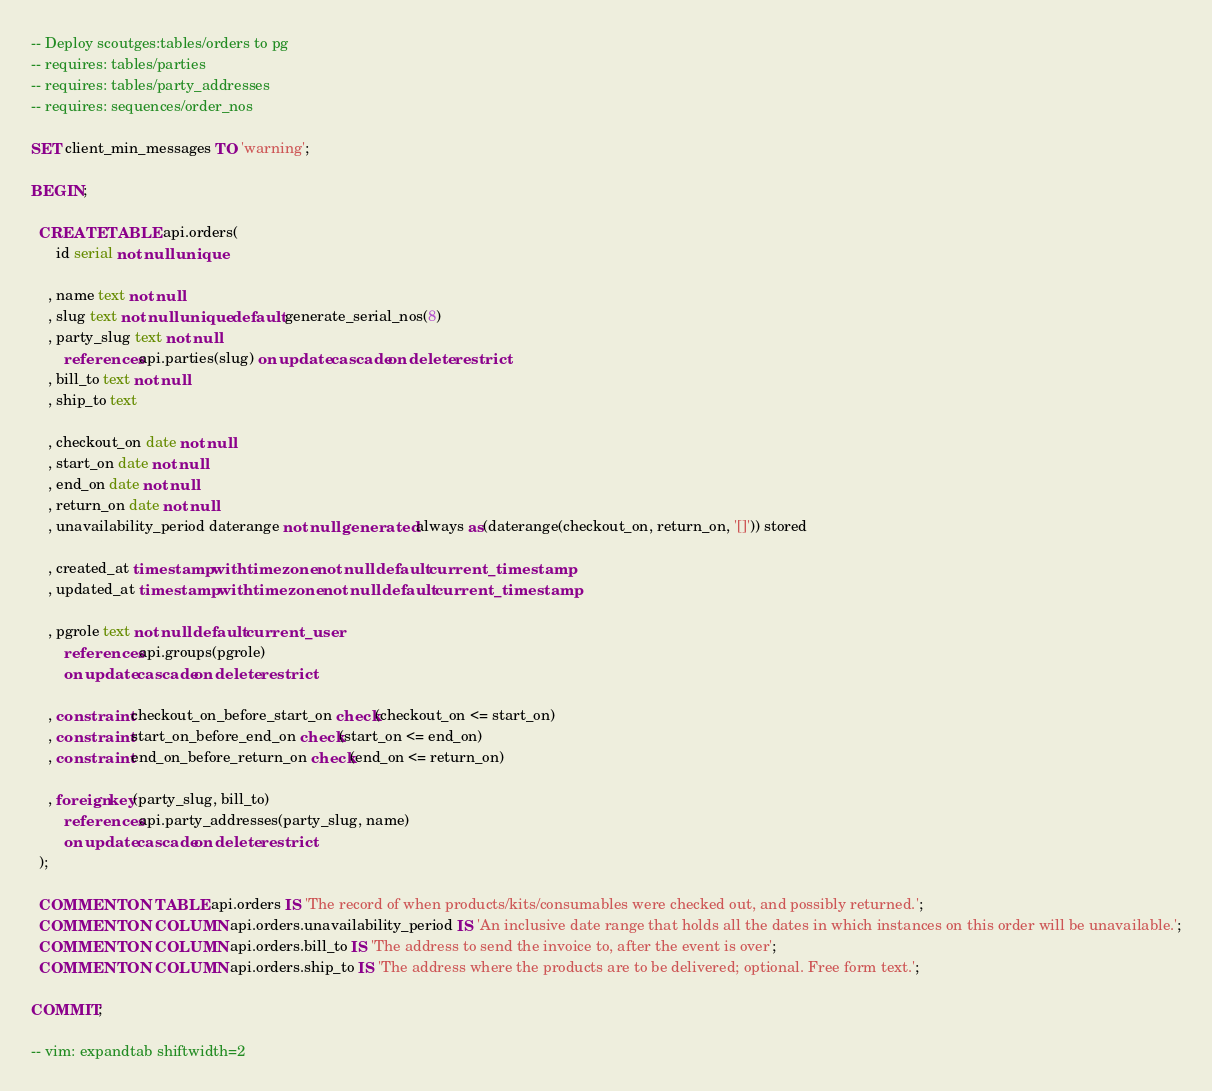<code> <loc_0><loc_0><loc_500><loc_500><_SQL_>-- Deploy scoutges:tables/orders to pg
-- requires: tables/parties
-- requires: tables/party_addresses
-- requires: sequences/order_nos

SET client_min_messages TO 'warning';

BEGIN;

  CREATE TABLE api.orders(
      id serial not null unique

    , name text not null
    , slug text not null unique default generate_serial_nos(8)
    , party_slug text not null
        references api.parties(slug) on update cascade on delete restrict
    , bill_to text not null
    , ship_to text

    , checkout_on date not null
    , start_on date not null
    , end_on date not null
    , return_on date not null
    , unavailability_period daterange not null generated always as(daterange(checkout_on, return_on, '[]')) stored

    , created_at timestamp with time zone not null default current_timestamp
    , updated_at timestamp with time zone not null default current_timestamp

    , pgrole text not null default current_user
        references api.groups(pgrole)
        on update cascade on delete restrict

    , constraint checkout_on_before_start_on check(checkout_on <= start_on)
    , constraint start_on_before_end_on check(start_on <= end_on)
    , constraint end_on_before_return_on check(end_on <= return_on)

    , foreign key(party_slug, bill_to)
        references api.party_addresses(party_slug, name)
        on update cascade on delete restrict
  );

  COMMENT ON TABLE api.orders IS 'The record of when products/kits/consumables were checked out, and possibly returned.';
  COMMENT ON COLUMN api.orders.unavailability_period IS 'An inclusive date range that holds all the dates in which instances on this order will be unavailable.';
  COMMENT ON COLUMN api.orders.bill_to IS 'The address to send the invoice to, after the event is over';
  COMMENT ON COLUMN api.orders.ship_to IS 'The address where the products are to be delivered; optional. Free form text.';

COMMIT;

-- vim: expandtab shiftwidth=2
</code> 